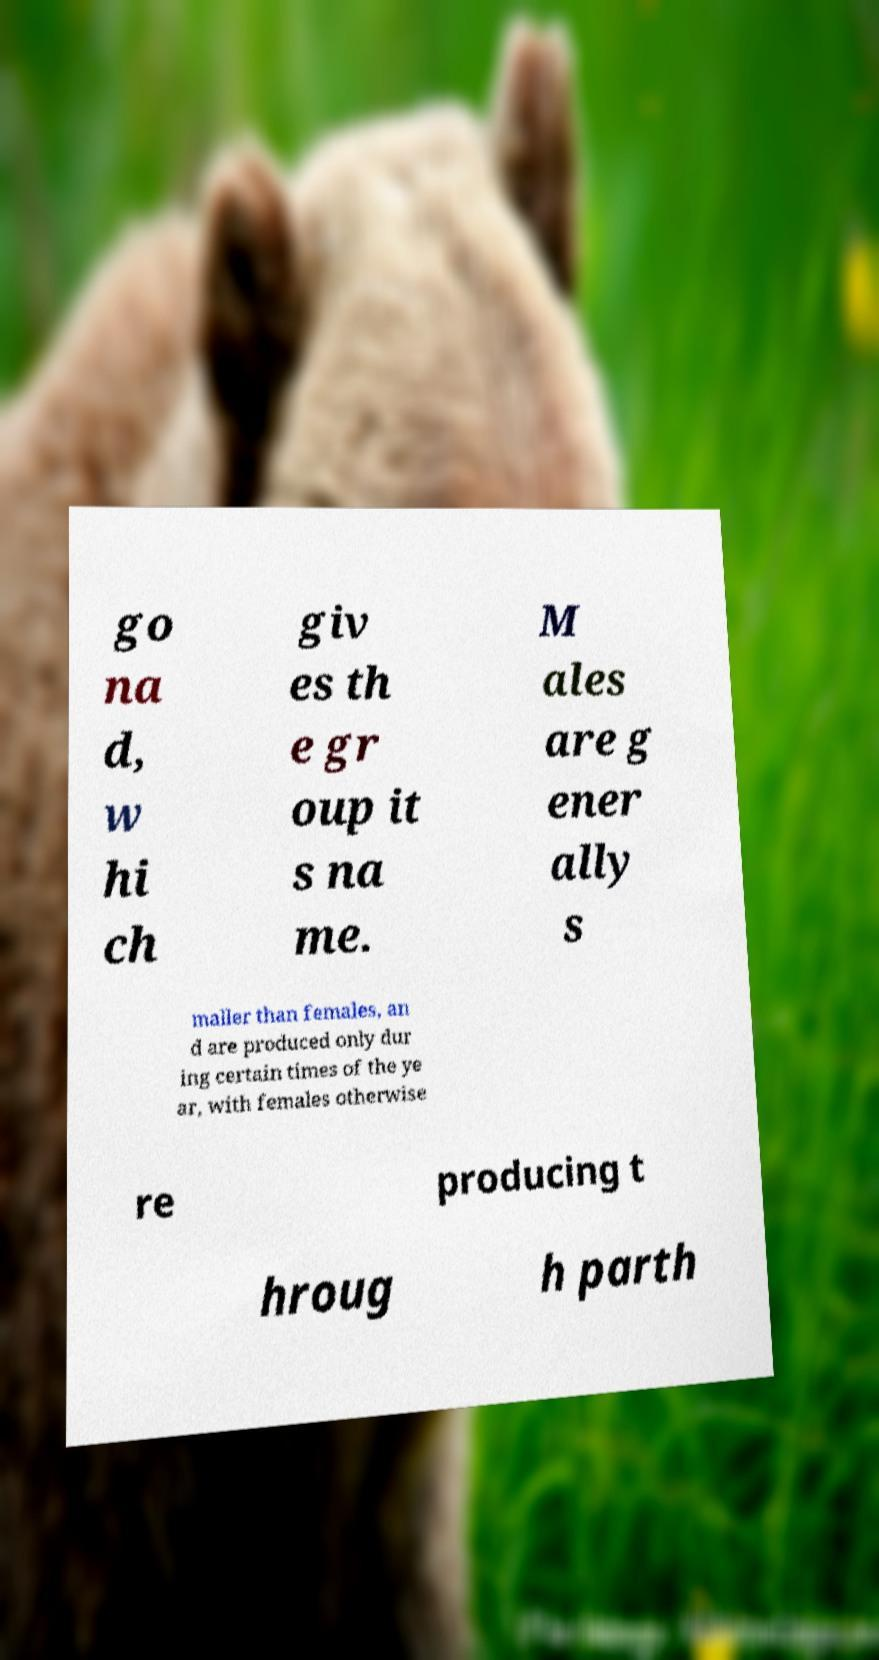What messages or text are displayed in this image? I need them in a readable, typed format. go na d, w hi ch giv es th e gr oup it s na me. M ales are g ener ally s maller than females, an d are produced only dur ing certain times of the ye ar, with females otherwise re producing t hroug h parth 